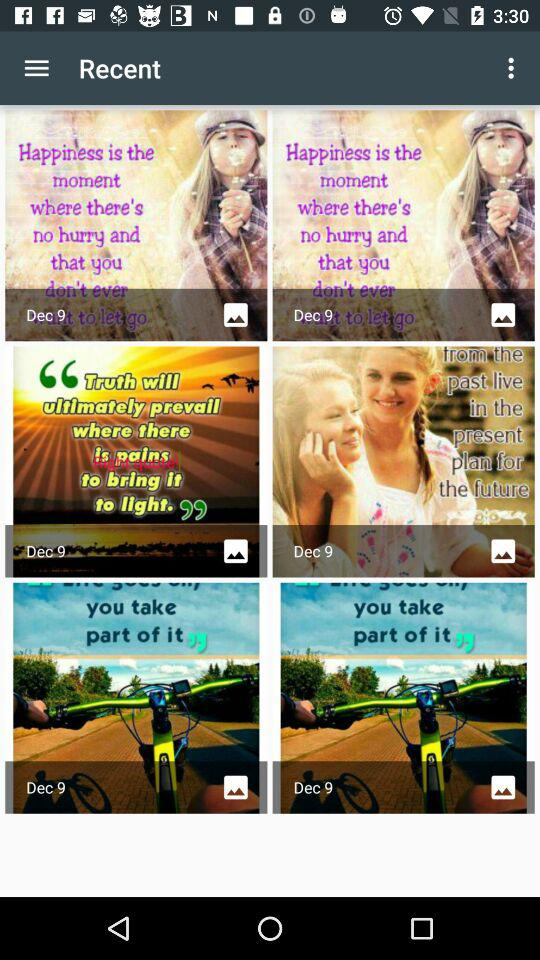What is the mentioned date for the images in "Recent"? The mentioned date for the images in "Recent" is December 9. 